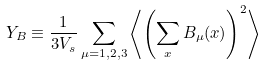<formula> <loc_0><loc_0><loc_500><loc_500>Y _ { B } \equiv \frac { 1 } { 3 V _ { s } } \sum _ { \mu = 1 , 2 , 3 } \left \langle \left ( \sum _ { x } B _ { \mu } ( x ) \right ) ^ { 2 } \right \rangle</formula> 